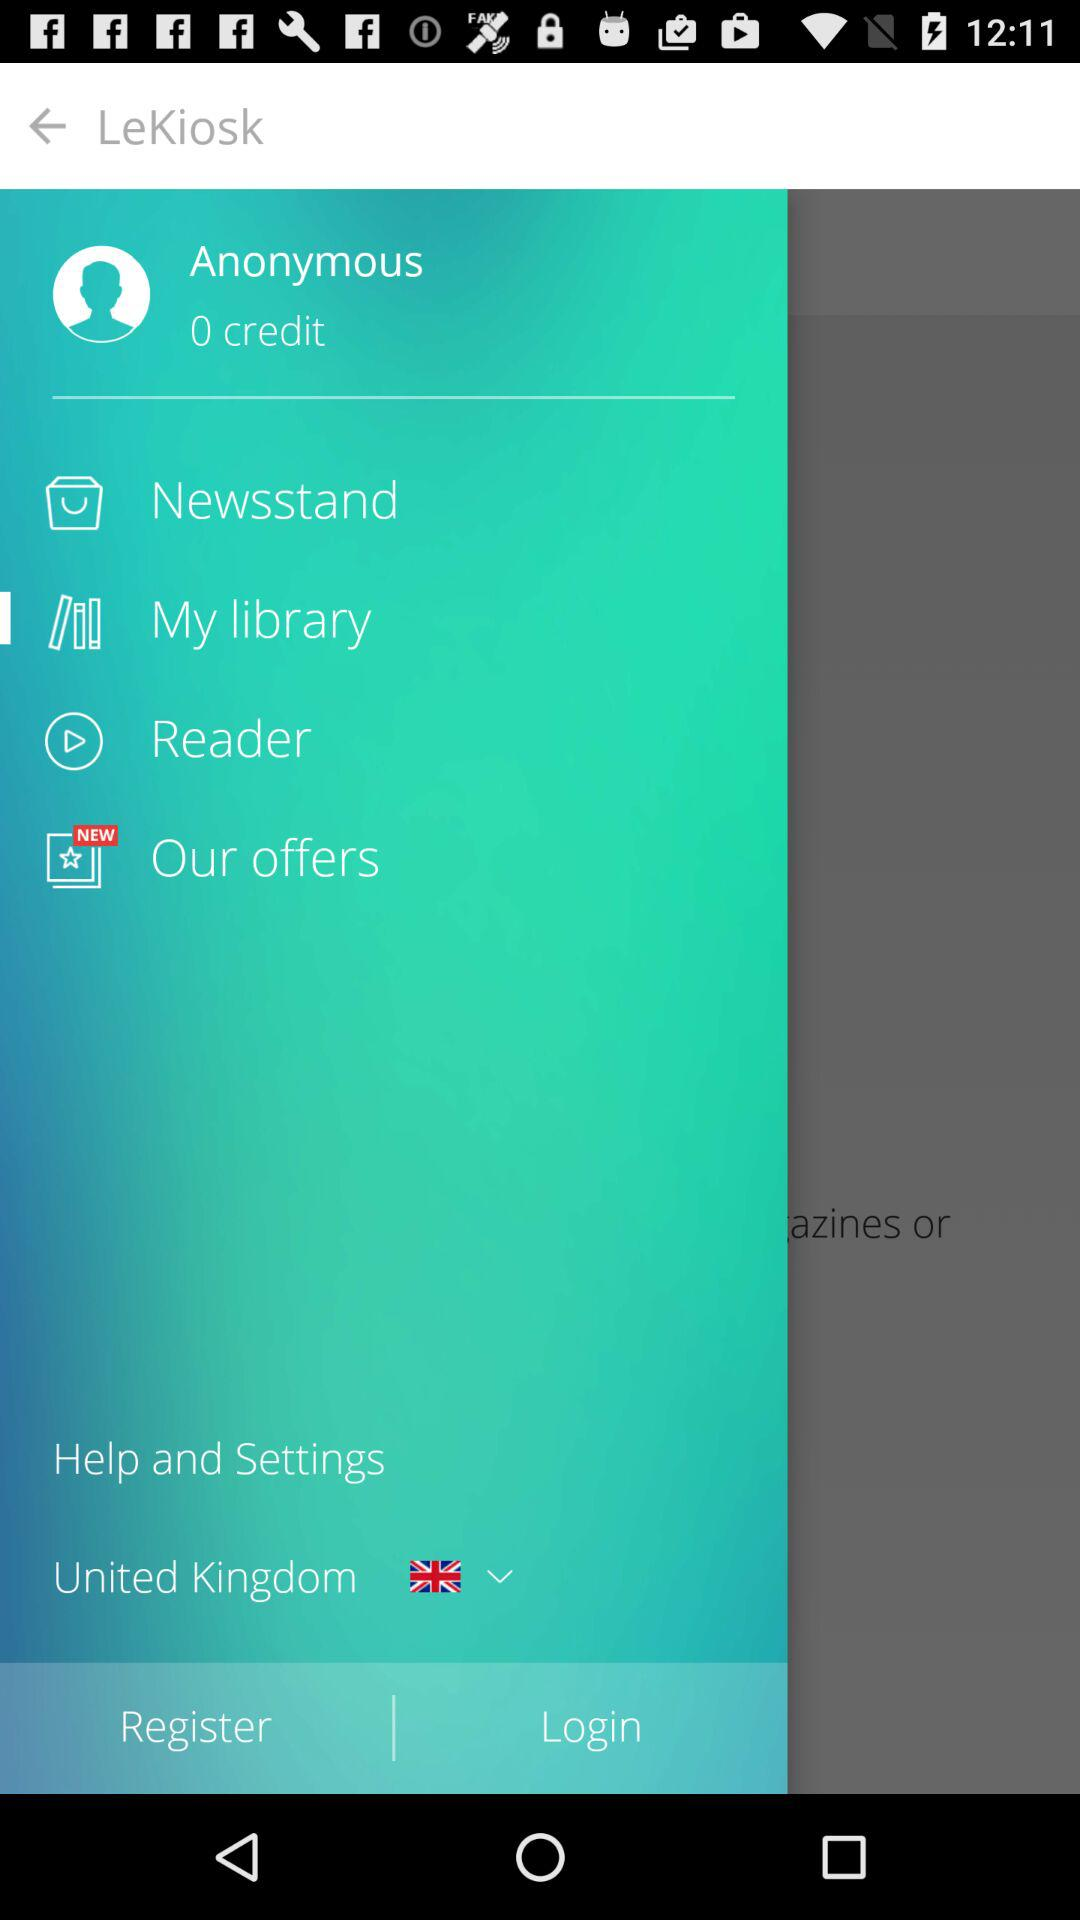What is the name of the application? The name of the application is "LeKiosk". 